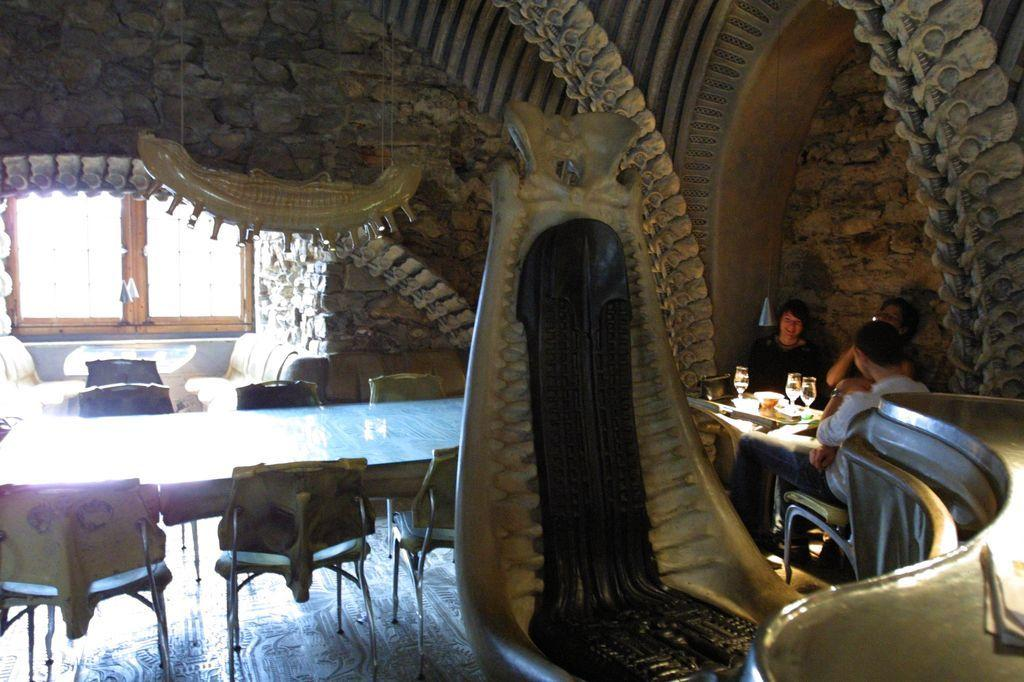What type of furniture is present in the room? There are chairs and tables in the room. Can you describe the window in the room? There is a window in the room. How many people are sitting at a table in the room? There are 3 people sitting on chairs at a table. What items can be found on the table? There are glasses and food items on the table. What type of food is the fireman eating in the image? There is no fireman present in the image, and therefore no such activity can be observed. 